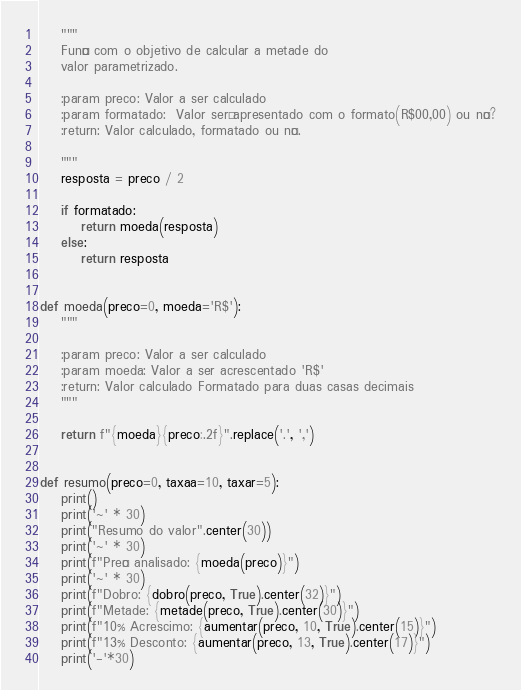<code> <loc_0><loc_0><loc_500><loc_500><_Python_>    """
    Função com o objetivo de calcular a metade do
    valor parametrizado.

    :param preco: Valor a ser calculado
    :param formatado:  Valor será apresentado com o formato(R$00,00) ou não?
    :return: Valor calculado, formatado ou não.

    """
    resposta = preco / 2

    if formatado:
        return moeda(resposta)
    else:
        return resposta


def moeda(preco=0, moeda='R$'):
    """

    :param preco: Valor a ser calculado
    :param moeda: Valor a ser acrescentado 'R$'
    :return: Valor calculado Formatado para duas casas decimais
    """

    return f"{moeda}{preco:.2f}".replace('.', ',')


def resumo(preco=0, taxaa=10, taxar=5):
    print()
    print('~' * 30)
    print("Resumo do valor".center(30))
    print('~' * 30)
    print(f"Preço analisado: {moeda(preco)}")
    print('~' * 30)
    print(f"Dobro: {dobro(preco, True).center(32)}")
    print(f"Metade: {metade(preco, True).center(30)}")
    print(f"10% Acrescimo: {aumentar(preco, 10, True).center(15)}")
    print(f"13% Desconto: {aumentar(preco, 13, True).center(17)}")
    print('-'*30)
</code> 